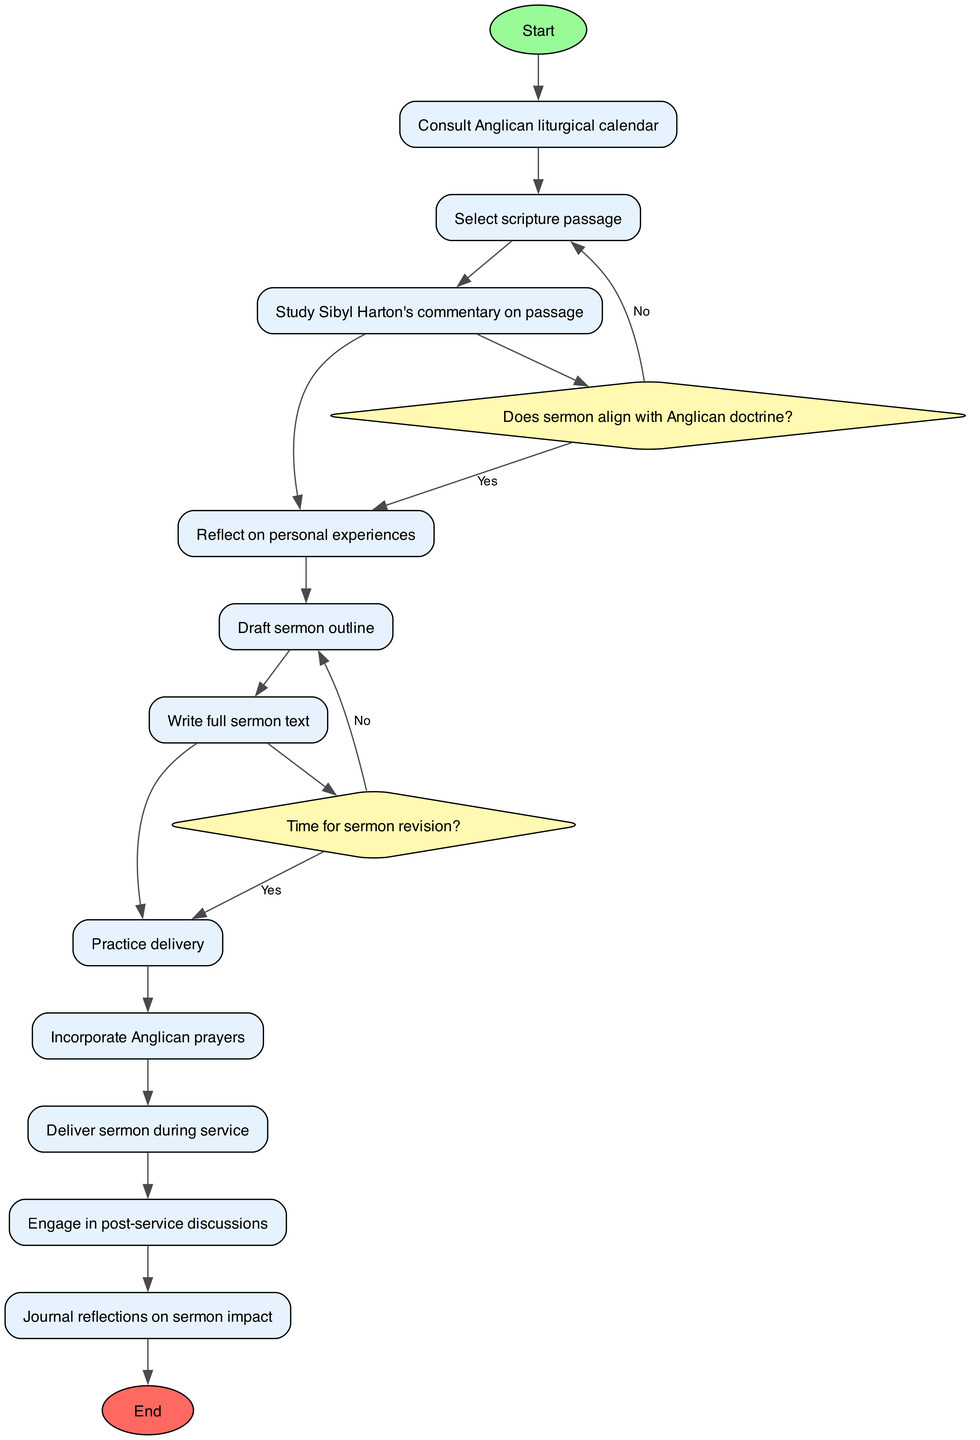What is the first activity in the diagram? The diagram starts with the node labeled "Begin sermon preparation," which is the first activity connected to the start node.
Answer: Begin sermon preparation How many decision nodes are present in the diagram? By counting the diamond-shaped nodes that represent decisions, there are two decision nodes shown in the diagram.
Answer: 2 What happens if the sermon does not align with Anglican doctrine? The diagram indicates that if the sermon does not align with Anglican doctrine, the process leads to the node "Revise content," indicating a need to edit the sermon.
Answer: Revise content Which activity comes directly after practicing delivery? Following the "Practice delivery" activity, the next activity shown in the diagram is "Incorporate Anglican prayers."
Answer: Incorporate Anglican prayers What is the last step in the process outlined in the diagram? The end node indicates that the process concludes after "Journal reflections on sermon impact," which is the last activity before reaching the end.
Answer: Complete sermon process What does the decision node regarding sermon revision ask? The decision node question regarding sermon revision is framed as "Time for sermon revision?" which requires reflection on whether additional editing is necessary.
Answer: Time for sermon revision? How does the diagram connect the activity "Select scripture passage"? The "Select scripture passage" is connected to the previous activity "Consult Anglican liturgical calendar," displaying a sequential flow in the preparation process.
Answer: Consult Anglican liturgical calendar What is the total number of activities listed in the diagram? By counting all the rectangular nodes that represent activities, the diagram outlines a total of eleven activities.
Answer: 11 What happens if there is no time for sermon revision? According to the diagram, if there is no time for sermon revision, the process leads directly to the "Finalize sermon" activity, indicating the conclusion of editing.
Answer: Finalize sermon 